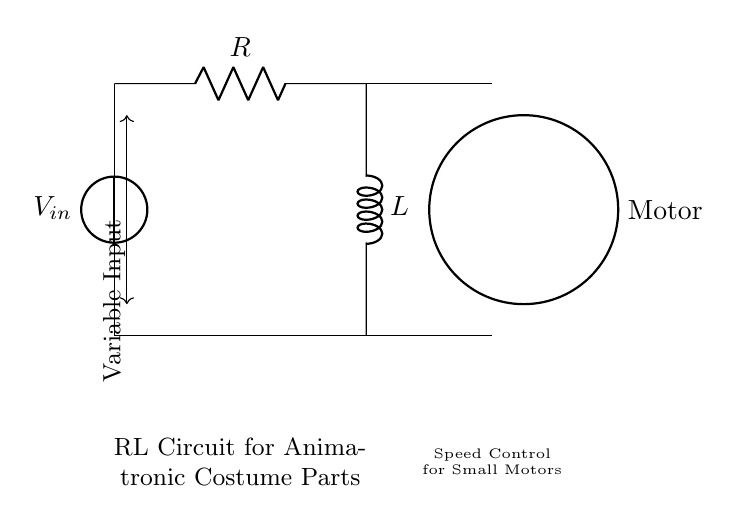What is the input voltage in this circuit? The input voltage is labeled as \( V_{in} \), which is shown near the voltage source symbol in the circuit diagram.
Answer: \( V_{in} \) What are the components in this RL circuit? The components of the RL circuit include a voltage source, a resistor, and an inductor, as indicated by the symbols in the diagram.
Answer: Voltage source, resistor, inductor What is the function of the motor in this circuit? The motor is connected to the output of the RL circuit and serves to convert electrical energy into mechanical motion, which is essential for animatronic costume parts.
Answer: Speed control How are the resistor and inductor connected in this circuit? The resistor and inductor are connected in series; the circuit diagram shows them arranged in a sequential layout, where the resistor comes first followed by the inductor before the motor.
Answer: Series What happens to the speed of the motor when the resistance increases? Increasing the resistance will reduce the current flowing through the circuit, leading to a decrease in the motor speed, as this affects the amount of power it receives.
Answer: Decreases Why is an RL circuit used for controlling motor speed? An RL circuit is preferred for motor speed control because the resistor limits current while the inductor provides a smooth response to changes in power, minimizing spikes and providing better control over speed.
Answer: Smooth control 